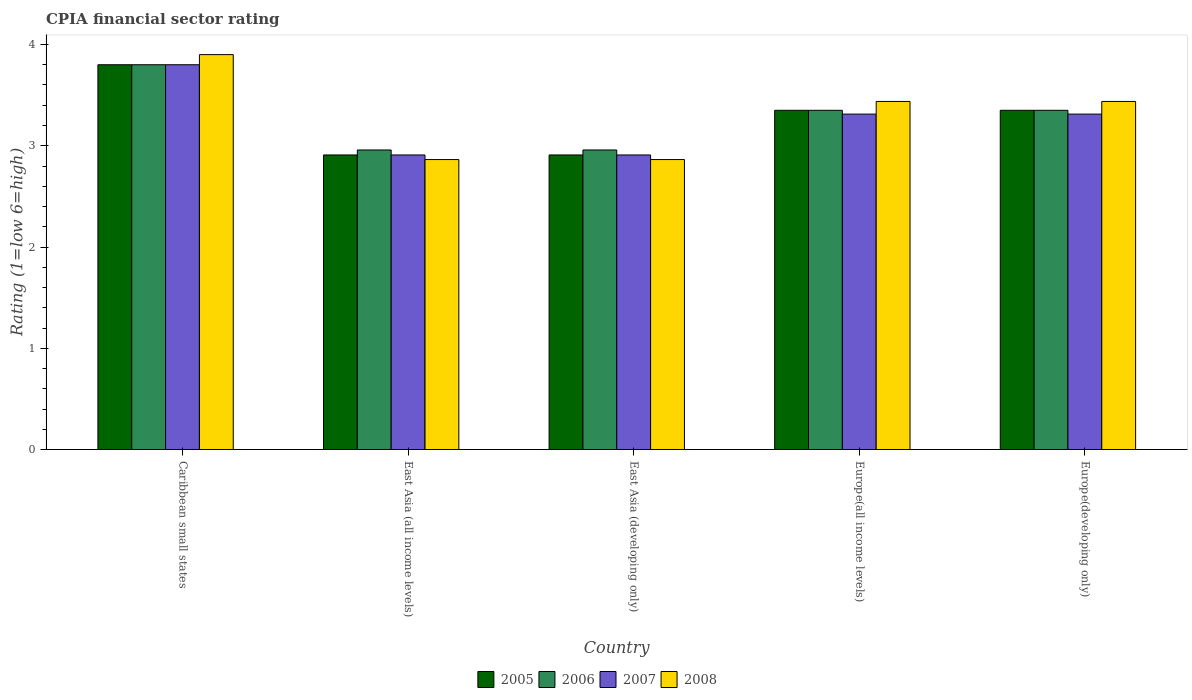How many different coloured bars are there?
Your answer should be very brief. 4. How many groups of bars are there?
Your answer should be very brief. 5. Are the number of bars per tick equal to the number of legend labels?
Offer a terse response. Yes. Are the number of bars on each tick of the X-axis equal?
Your answer should be compact. Yes. How many bars are there on the 1st tick from the right?
Offer a terse response. 4. What is the label of the 1st group of bars from the left?
Provide a succinct answer. Caribbean small states. In how many cases, is the number of bars for a given country not equal to the number of legend labels?
Make the answer very short. 0. What is the CPIA rating in 2005 in Europe(developing only)?
Offer a very short reply. 3.35. Across all countries, what is the minimum CPIA rating in 2005?
Offer a terse response. 2.91. In which country was the CPIA rating in 2005 maximum?
Provide a short and direct response. Caribbean small states. In which country was the CPIA rating in 2006 minimum?
Your answer should be compact. East Asia (all income levels). What is the total CPIA rating in 2006 in the graph?
Provide a succinct answer. 16.42. What is the difference between the CPIA rating in 2008 in Caribbean small states and that in East Asia (all income levels)?
Offer a very short reply. 1.04. What is the difference between the CPIA rating in 2006 in Europe(all income levels) and the CPIA rating in 2008 in East Asia (developing only)?
Keep it short and to the point. 0.49. What is the average CPIA rating in 2007 per country?
Your answer should be compact. 3.25. What is the difference between the CPIA rating of/in 2005 and CPIA rating of/in 2008 in East Asia (all income levels)?
Provide a succinct answer. 0.05. What is the ratio of the CPIA rating in 2007 in East Asia (developing only) to that in Europe(developing only)?
Offer a terse response. 0.88. What is the difference between the highest and the second highest CPIA rating in 2008?
Your response must be concise. -0.46. What is the difference between the highest and the lowest CPIA rating in 2008?
Ensure brevity in your answer.  1.04. Is the sum of the CPIA rating in 2007 in Caribbean small states and East Asia (developing only) greater than the maximum CPIA rating in 2005 across all countries?
Your answer should be very brief. Yes. What does the 2nd bar from the left in East Asia (developing only) represents?
Your response must be concise. 2006. What does the 2nd bar from the right in Caribbean small states represents?
Keep it short and to the point. 2007. Is it the case that in every country, the sum of the CPIA rating in 2007 and CPIA rating in 2008 is greater than the CPIA rating in 2005?
Offer a very short reply. Yes. How many bars are there?
Make the answer very short. 20. How many legend labels are there?
Your answer should be very brief. 4. What is the title of the graph?
Your response must be concise. CPIA financial sector rating. Does "2014" appear as one of the legend labels in the graph?
Give a very brief answer. No. What is the Rating (1=low 6=high) in 2008 in Caribbean small states?
Your response must be concise. 3.9. What is the Rating (1=low 6=high) in 2005 in East Asia (all income levels)?
Keep it short and to the point. 2.91. What is the Rating (1=low 6=high) in 2006 in East Asia (all income levels)?
Your response must be concise. 2.96. What is the Rating (1=low 6=high) in 2007 in East Asia (all income levels)?
Your answer should be very brief. 2.91. What is the Rating (1=low 6=high) of 2008 in East Asia (all income levels)?
Your answer should be very brief. 2.86. What is the Rating (1=low 6=high) of 2005 in East Asia (developing only)?
Provide a succinct answer. 2.91. What is the Rating (1=low 6=high) in 2006 in East Asia (developing only)?
Your answer should be compact. 2.96. What is the Rating (1=low 6=high) of 2007 in East Asia (developing only)?
Offer a terse response. 2.91. What is the Rating (1=low 6=high) in 2008 in East Asia (developing only)?
Provide a succinct answer. 2.86. What is the Rating (1=low 6=high) in 2005 in Europe(all income levels)?
Your response must be concise. 3.35. What is the Rating (1=low 6=high) in 2006 in Europe(all income levels)?
Give a very brief answer. 3.35. What is the Rating (1=low 6=high) of 2007 in Europe(all income levels)?
Keep it short and to the point. 3.31. What is the Rating (1=low 6=high) of 2008 in Europe(all income levels)?
Provide a short and direct response. 3.44. What is the Rating (1=low 6=high) of 2005 in Europe(developing only)?
Your answer should be very brief. 3.35. What is the Rating (1=low 6=high) in 2006 in Europe(developing only)?
Provide a succinct answer. 3.35. What is the Rating (1=low 6=high) of 2007 in Europe(developing only)?
Make the answer very short. 3.31. What is the Rating (1=low 6=high) in 2008 in Europe(developing only)?
Provide a short and direct response. 3.44. Across all countries, what is the maximum Rating (1=low 6=high) in 2005?
Your response must be concise. 3.8. Across all countries, what is the maximum Rating (1=low 6=high) in 2008?
Provide a short and direct response. 3.9. Across all countries, what is the minimum Rating (1=low 6=high) of 2005?
Your answer should be very brief. 2.91. Across all countries, what is the minimum Rating (1=low 6=high) of 2006?
Give a very brief answer. 2.96. Across all countries, what is the minimum Rating (1=low 6=high) of 2007?
Offer a very short reply. 2.91. Across all countries, what is the minimum Rating (1=low 6=high) in 2008?
Ensure brevity in your answer.  2.86. What is the total Rating (1=low 6=high) of 2005 in the graph?
Your answer should be very brief. 16.32. What is the total Rating (1=low 6=high) of 2006 in the graph?
Keep it short and to the point. 16.42. What is the total Rating (1=low 6=high) of 2007 in the graph?
Provide a succinct answer. 16.24. What is the total Rating (1=low 6=high) in 2008 in the graph?
Your response must be concise. 16.5. What is the difference between the Rating (1=low 6=high) of 2005 in Caribbean small states and that in East Asia (all income levels)?
Make the answer very short. 0.89. What is the difference between the Rating (1=low 6=high) in 2006 in Caribbean small states and that in East Asia (all income levels)?
Give a very brief answer. 0.84. What is the difference between the Rating (1=low 6=high) of 2007 in Caribbean small states and that in East Asia (all income levels)?
Your response must be concise. 0.89. What is the difference between the Rating (1=low 6=high) of 2008 in Caribbean small states and that in East Asia (all income levels)?
Give a very brief answer. 1.04. What is the difference between the Rating (1=low 6=high) of 2005 in Caribbean small states and that in East Asia (developing only)?
Ensure brevity in your answer.  0.89. What is the difference between the Rating (1=low 6=high) in 2006 in Caribbean small states and that in East Asia (developing only)?
Make the answer very short. 0.84. What is the difference between the Rating (1=low 6=high) in 2007 in Caribbean small states and that in East Asia (developing only)?
Keep it short and to the point. 0.89. What is the difference between the Rating (1=low 6=high) of 2008 in Caribbean small states and that in East Asia (developing only)?
Make the answer very short. 1.04. What is the difference between the Rating (1=low 6=high) in 2005 in Caribbean small states and that in Europe(all income levels)?
Your answer should be very brief. 0.45. What is the difference between the Rating (1=low 6=high) in 2006 in Caribbean small states and that in Europe(all income levels)?
Your answer should be very brief. 0.45. What is the difference between the Rating (1=low 6=high) in 2007 in Caribbean small states and that in Europe(all income levels)?
Your answer should be compact. 0.49. What is the difference between the Rating (1=low 6=high) of 2008 in Caribbean small states and that in Europe(all income levels)?
Offer a terse response. 0.46. What is the difference between the Rating (1=low 6=high) of 2005 in Caribbean small states and that in Europe(developing only)?
Make the answer very short. 0.45. What is the difference between the Rating (1=low 6=high) of 2006 in Caribbean small states and that in Europe(developing only)?
Offer a very short reply. 0.45. What is the difference between the Rating (1=low 6=high) in 2007 in Caribbean small states and that in Europe(developing only)?
Offer a very short reply. 0.49. What is the difference between the Rating (1=low 6=high) in 2008 in Caribbean small states and that in Europe(developing only)?
Offer a terse response. 0.46. What is the difference between the Rating (1=low 6=high) in 2005 in East Asia (all income levels) and that in East Asia (developing only)?
Keep it short and to the point. 0. What is the difference between the Rating (1=low 6=high) of 2008 in East Asia (all income levels) and that in East Asia (developing only)?
Provide a succinct answer. 0. What is the difference between the Rating (1=low 6=high) in 2005 in East Asia (all income levels) and that in Europe(all income levels)?
Provide a short and direct response. -0.44. What is the difference between the Rating (1=low 6=high) of 2006 in East Asia (all income levels) and that in Europe(all income levels)?
Keep it short and to the point. -0.39. What is the difference between the Rating (1=low 6=high) in 2007 in East Asia (all income levels) and that in Europe(all income levels)?
Your answer should be very brief. -0.4. What is the difference between the Rating (1=low 6=high) in 2008 in East Asia (all income levels) and that in Europe(all income levels)?
Offer a terse response. -0.57. What is the difference between the Rating (1=low 6=high) in 2005 in East Asia (all income levels) and that in Europe(developing only)?
Ensure brevity in your answer.  -0.44. What is the difference between the Rating (1=low 6=high) of 2006 in East Asia (all income levels) and that in Europe(developing only)?
Provide a short and direct response. -0.39. What is the difference between the Rating (1=low 6=high) of 2007 in East Asia (all income levels) and that in Europe(developing only)?
Offer a terse response. -0.4. What is the difference between the Rating (1=low 6=high) in 2008 in East Asia (all income levels) and that in Europe(developing only)?
Your answer should be compact. -0.57. What is the difference between the Rating (1=low 6=high) of 2005 in East Asia (developing only) and that in Europe(all income levels)?
Offer a very short reply. -0.44. What is the difference between the Rating (1=low 6=high) of 2006 in East Asia (developing only) and that in Europe(all income levels)?
Provide a short and direct response. -0.39. What is the difference between the Rating (1=low 6=high) of 2007 in East Asia (developing only) and that in Europe(all income levels)?
Give a very brief answer. -0.4. What is the difference between the Rating (1=low 6=high) in 2008 in East Asia (developing only) and that in Europe(all income levels)?
Offer a very short reply. -0.57. What is the difference between the Rating (1=low 6=high) in 2005 in East Asia (developing only) and that in Europe(developing only)?
Provide a succinct answer. -0.44. What is the difference between the Rating (1=low 6=high) of 2006 in East Asia (developing only) and that in Europe(developing only)?
Provide a short and direct response. -0.39. What is the difference between the Rating (1=low 6=high) in 2007 in East Asia (developing only) and that in Europe(developing only)?
Provide a short and direct response. -0.4. What is the difference between the Rating (1=low 6=high) of 2008 in East Asia (developing only) and that in Europe(developing only)?
Provide a succinct answer. -0.57. What is the difference between the Rating (1=low 6=high) in 2005 in Europe(all income levels) and that in Europe(developing only)?
Give a very brief answer. 0. What is the difference between the Rating (1=low 6=high) of 2006 in Europe(all income levels) and that in Europe(developing only)?
Provide a short and direct response. 0. What is the difference between the Rating (1=low 6=high) in 2007 in Europe(all income levels) and that in Europe(developing only)?
Offer a terse response. 0. What is the difference between the Rating (1=low 6=high) in 2005 in Caribbean small states and the Rating (1=low 6=high) in 2006 in East Asia (all income levels)?
Give a very brief answer. 0.84. What is the difference between the Rating (1=low 6=high) in 2005 in Caribbean small states and the Rating (1=low 6=high) in 2007 in East Asia (all income levels)?
Offer a very short reply. 0.89. What is the difference between the Rating (1=low 6=high) in 2005 in Caribbean small states and the Rating (1=low 6=high) in 2008 in East Asia (all income levels)?
Keep it short and to the point. 0.94. What is the difference between the Rating (1=low 6=high) of 2006 in Caribbean small states and the Rating (1=low 6=high) of 2007 in East Asia (all income levels)?
Your response must be concise. 0.89. What is the difference between the Rating (1=low 6=high) in 2006 in Caribbean small states and the Rating (1=low 6=high) in 2008 in East Asia (all income levels)?
Offer a very short reply. 0.94. What is the difference between the Rating (1=low 6=high) in 2007 in Caribbean small states and the Rating (1=low 6=high) in 2008 in East Asia (all income levels)?
Keep it short and to the point. 0.94. What is the difference between the Rating (1=low 6=high) in 2005 in Caribbean small states and the Rating (1=low 6=high) in 2006 in East Asia (developing only)?
Ensure brevity in your answer.  0.84. What is the difference between the Rating (1=low 6=high) in 2005 in Caribbean small states and the Rating (1=low 6=high) in 2007 in East Asia (developing only)?
Your response must be concise. 0.89. What is the difference between the Rating (1=low 6=high) in 2005 in Caribbean small states and the Rating (1=low 6=high) in 2008 in East Asia (developing only)?
Your answer should be very brief. 0.94. What is the difference between the Rating (1=low 6=high) in 2006 in Caribbean small states and the Rating (1=low 6=high) in 2007 in East Asia (developing only)?
Offer a terse response. 0.89. What is the difference between the Rating (1=low 6=high) in 2006 in Caribbean small states and the Rating (1=low 6=high) in 2008 in East Asia (developing only)?
Your answer should be very brief. 0.94. What is the difference between the Rating (1=low 6=high) of 2007 in Caribbean small states and the Rating (1=low 6=high) of 2008 in East Asia (developing only)?
Offer a terse response. 0.94. What is the difference between the Rating (1=low 6=high) of 2005 in Caribbean small states and the Rating (1=low 6=high) of 2006 in Europe(all income levels)?
Offer a very short reply. 0.45. What is the difference between the Rating (1=low 6=high) of 2005 in Caribbean small states and the Rating (1=low 6=high) of 2007 in Europe(all income levels)?
Make the answer very short. 0.49. What is the difference between the Rating (1=low 6=high) in 2005 in Caribbean small states and the Rating (1=low 6=high) in 2008 in Europe(all income levels)?
Your response must be concise. 0.36. What is the difference between the Rating (1=low 6=high) of 2006 in Caribbean small states and the Rating (1=low 6=high) of 2007 in Europe(all income levels)?
Keep it short and to the point. 0.49. What is the difference between the Rating (1=low 6=high) in 2006 in Caribbean small states and the Rating (1=low 6=high) in 2008 in Europe(all income levels)?
Provide a succinct answer. 0.36. What is the difference between the Rating (1=low 6=high) of 2007 in Caribbean small states and the Rating (1=low 6=high) of 2008 in Europe(all income levels)?
Offer a terse response. 0.36. What is the difference between the Rating (1=low 6=high) of 2005 in Caribbean small states and the Rating (1=low 6=high) of 2006 in Europe(developing only)?
Give a very brief answer. 0.45. What is the difference between the Rating (1=low 6=high) in 2005 in Caribbean small states and the Rating (1=low 6=high) in 2007 in Europe(developing only)?
Offer a terse response. 0.49. What is the difference between the Rating (1=low 6=high) of 2005 in Caribbean small states and the Rating (1=low 6=high) of 2008 in Europe(developing only)?
Your response must be concise. 0.36. What is the difference between the Rating (1=low 6=high) in 2006 in Caribbean small states and the Rating (1=low 6=high) in 2007 in Europe(developing only)?
Make the answer very short. 0.49. What is the difference between the Rating (1=low 6=high) in 2006 in Caribbean small states and the Rating (1=low 6=high) in 2008 in Europe(developing only)?
Keep it short and to the point. 0.36. What is the difference between the Rating (1=low 6=high) in 2007 in Caribbean small states and the Rating (1=low 6=high) in 2008 in Europe(developing only)?
Give a very brief answer. 0.36. What is the difference between the Rating (1=low 6=high) in 2005 in East Asia (all income levels) and the Rating (1=low 6=high) in 2006 in East Asia (developing only)?
Make the answer very short. -0.05. What is the difference between the Rating (1=low 6=high) in 2005 in East Asia (all income levels) and the Rating (1=low 6=high) in 2007 in East Asia (developing only)?
Offer a very short reply. 0. What is the difference between the Rating (1=low 6=high) of 2005 in East Asia (all income levels) and the Rating (1=low 6=high) of 2008 in East Asia (developing only)?
Provide a succinct answer. 0.05. What is the difference between the Rating (1=low 6=high) of 2006 in East Asia (all income levels) and the Rating (1=low 6=high) of 2007 in East Asia (developing only)?
Ensure brevity in your answer.  0.05. What is the difference between the Rating (1=low 6=high) of 2006 in East Asia (all income levels) and the Rating (1=low 6=high) of 2008 in East Asia (developing only)?
Your answer should be very brief. 0.09. What is the difference between the Rating (1=low 6=high) of 2007 in East Asia (all income levels) and the Rating (1=low 6=high) of 2008 in East Asia (developing only)?
Ensure brevity in your answer.  0.05. What is the difference between the Rating (1=low 6=high) of 2005 in East Asia (all income levels) and the Rating (1=low 6=high) of 2006 in Europe(all income levels)?
Your answer should be very brief. -0.44. What is the difference between the Rating (1=low 6=high) in 2005 in East Asia (all income levels) and the Rating (1=low 6=high) in 2007 in Europe(all income levels)?
Provide a succinct answer. -0.4. What is the difference between the Rating (1=low 6=high) of 2005 in East Asia (all income levels) and the Rating (1=low 6=high) of 2008 in Europe(all income levels)?
Provide a succinct answer. -0.53. What is the difference between the Rating (1=low 6=high) in 2006 in East Asia (all income levels) and the Rating (1=low 6=high) in 2007 in Europe(all income levels)?
Ensure brevity in your answer.  -0.35. What is the difference between the Rating (1=low 6=high) in 2006 in East Asia (all income levels) and the Rating (1=low 6=high) in 2008 in Europe(all income levels)?
Make the answer very short. -0.48. What is the difference between the Rating (1=low 6=high) of 2007 in East Asia (all income levels) and the Rating (1=low 6=high) of 2008 in Europe(all income levels)?
Make the answer very short. -0.53. What is the difference between the Rating (1=low 6=high) in 2005 in East Asia (all income levels) and the Rating (1=low 6=high) in 2006 in Europe(developing only)?
Provide a short and direct response. -0.44. What is the difference between the Rating (1=low 6=high) of 2005 in East Asia (all income levels) and the Rating (1=low 6=high) of 2007 in Europe(developing only)?
Provide a succinct answer. -0.4. What is the difference between the Rating (1=low 6=high) of 2005 in East Asia (all income levels) and the Rating (1=low 6=high) of 2008 in Europe(developing only)?
Provide a short and direct response. -0.53. What is the difference between the Rating (1=low 6=high) in 2006 in East Asia (all income levels) and the Rating (1=low 6=high) in 2007 in Europe(developing only)?
Make the answer very short. -0.35. What is the difference between the Rating (1=low 6=high) of 2006 in East Asia (all income levels) and the Rating (1=low 6=high) of 2008 in Europe(developing only)?
Offer a terse response. -0.48. What is the difference between the Rating (1=low 6=high) in 2007 in East Asia (all income levels) and the Rating (1=low 6=high) in 2008 in Europe(developing only)?
Give a very brief answer. -0.53. What is the difference between the Rating (1=low 6=high) in 2005 in East Asia (developing only) and the Rating (1=low 6=high) in 2006 in Europe(all income levels)?
Offer a terse response. -0.44. What is the difference between the Rating (1=low 6=high) of 2005 in East Asia (developing only) and the Rating (1=low 6=high) of 2007 in Europe(all income levels)?
Provide a succinct answer. -0.4. What is the difference between the Rating (1=low 6=high) in 2005 in East Asia (developing only) and the Rating (1=low 6=high) in 2008 in Europe(all income levels)?
Ensure brevity in your answer.  -0.53. What is the difference between the Rating (1=low 6=high) of 2006 in East Asia (developing only) and the Rating (1=low 6=high) of 2007 in Europe(all income levels)?
Your answer should be compact. -0.35. What is the difference between the Rating (1=low 6=high) of 2006 in East Asia (developing only) and the Rating (1=low 6=high) of 2008 in Europe(all income levels)?
Keep it short and to the point. -0.48. What is the difference between the Rating (1=low 6=high) of 2007 in East Asia (developing only) and the Rating (1=low 6=high) of 2008 in Europe(all income levels)?
Your answer should be very brief. -0.53. What is the difference between the Rating (1=low 6=high) of 2005 in East Asia (developing only) and the Rating (1=low 6=high) of 2006 in Europe(developing only)?
Your response must be concise. -0.44. What is the difference between the Rating (1=low 6=high) of 2005 in East Asia (developing only) and the Rating (1=low 6=high) of 2007 in Europe(developing only)?
Your answer should be compact. -0.4. What is the difference between the Rating (1=low 6=high) in 2005 in East Asia (developing only) and the Rating (1=low 6=high) in 2008 in Europe(developing only)?
Ensure brevity in your answer.  -0.53. What is the difference between the Rating (1=low 6=high) in 2006 in East Asia (developing only) and the Rating (1=low 6=high) in 2007 in Europe(developing only)?
Your answer should be compact. -0.35. What is the difference between the Rating (1=low 6=high) of 2006 in East Asia (developing only) and the Rating (1=low 6=high) of 2008 in Europe(developing only)?
Keep it short and to the point. -0.48. What is the difference between the Rating (1=low 6=high) of 2007 in East Asia (developing only) and the Rating (1=low 6=high) of 2008 in Europe(developing only)?
Give a very brief answer. -0.53. What is the difference between the Rating (1=low 6=high) in 2005 in Europe(all income levels) and the Rating (1=low 6=high) in 2006 in Europe(developing only)?
Your answer should be compact. 0. What is the difference between the Rating (1=low 6=high) in 2005 in Europe(all income levels) and the Rating (1=low 6=high) in 2007 in Europe(developing only)?
Provide a succinct answer. 0.04. What is the difference between the Rating (1=low 6=high) in 2005 in Europe(all income levels) and the Rating (1=low 6=high) in 2008 in Europe(developing only)?
Provide a succinct answer. -0.09. What is the difference between the Rating (1=low 6=high) of 2006 in Europe(all income levels) and the Rating (1=low 6=high) of 2007 in Europe(developing only)?
Offer a very short reply. 0.04. What is the difference between the Rating (1=low 6=high) in 2006 in Europe(all income levels) and the Rating (1=low 6=high) in 2008 in Europe(developing only)?
Your response must be concise. -0.09. What is the difference between the Rating (1=low 6=high) of 2007 in Europe(all income levels) and the Rating (1=low 6=high) of 2008 in Europe(developing only)?
Offer a terse response. -0.12. What is the average Rating (1=low 6=high) of 2005 per country?
Your answer should be compact. 3.26. What is the average Rating (1=low 6=high) in 2006 per country?
Offer a terse response. 3.28. What is the average Rating (1=low 6=high) of 2007 per country?
Keep it short and to the point. 3.25. What is the average Rating (1=low 6=high) of 2008 per country?
Your response must be concise. 3.3. What is the difference between the Rating (1=low 6=high) of 2005 and Rating (1=low 6=high) of 2006 in Caribbean small states?
Provide a succinct answer. 0. What is the difference between the Rating (1=low 6=high) in 2005 and Rating (1=low 6=high) in 2007 in Caribbean small states?
Ensure brevity in your answer.  0. What is the difference between the Rating (1=low 6=high) in 2007 and Rating (1=low 6=high) in 2008 in Caribbean small states?
Provide a short and direct response. -0.1. What is the difference between the Rating (1=low 6=high) in 2005 and Rating (1=low 6=high) in 2006 in East Asia (all income levels)?
Ensure brevity in your answer.  -0.05. What is the difference between the Rating (1=low 6=high) in 2005 and Rating (1=low 6=high) in 2008 in East Asia (all income levels)?
Your answer should be very brief. 0.05. What is the difference between the Rating (1=low 6=high) of 2006 and Rating (1=low 6=high) of 2007 in East Asia (all income levels)?
Your response must be concise. 0.05. What is the difference between the Rating (1=low 6=high) of 2006 and Rating (1=low 6=high) of 2008 in East Asia (all income levels)?
Provide a succinct answer. 0.09. What is the difference between the Rating (1=low 6=high) in 2007 and Rating (1=low 6=high) in 2008 in East Asia (all income levels)?
Give a very brief answer. 0.05. What is the difference between the Rating (1=low 6=high) in 2005 and Rating (1=low 6=high) in 2006 in East Asia (developing only)?
Provide a short and direct response. -0.05. What is the difference between the Rating (1=low 6=high) of 2005 and Rating (1=low 6=high) of 2008 in East Asia (developing only)?
Keep it short and to the point. 0.05. What is the difference between the Rating (1=low 6=high) of 2006 and Rating (1=low 6=high) of 2007 in East Asia (developing only)?
Keep it short and to the point. 0.05. What is the difference between the Rating (1=low 6=high) of 2006 and Rating (1=low 6=high) of 2008 in East Asia (developing only)?
Your response must be concise. 0.09. What is the difference between the Rating (1=low 6=high) of 2007 and Rating (1=low 6=high) of 2008 in East Asia (developing only)?
Provide a short and direct response. 0.05. What is the difference between the Rating (1=low 6=high) in 2005 and Rating (1=low 6=high) in 2006 in Europe(all income levels)?
Make the answer very short. 0. What is the difference between the Rating (1=low 6=high) of 2005 and Rating (1=low 6=high) of 2007 in Europe(all income levels)?
Your response must be concise. 0.04. What is the difference between the Rating (1=low 6=high) in 2005 and Rating (1=low 6=high) in 2008 in Europe(all income levels)?
Your response must be concise. -0.09. What is the difference between the Rating (1=low 6=high) of 2006 and Rating (1=low 6=high) of 2007 in Europe(all income levels)?
Give a very brief answer. 0.04. What is the difference between the Rating (1=low 6=high) in 2006 and Rating (1=low 6=high) in 2008 in Europe(all income levels)?
Provide a succinct answer. -0.09. What is the difference between the Rating (1=low 6=high) of 2007 and Rating (1=low 6=high) of 2008 in Europe(all income levels)?
Your answer should be very brief. -0.12. What is the difference between the Rating (1=low 6=high) in 2005 and Rating (1=low 6=high) in 2006 in Europe(developing only)?
Offer a very short reply. 0. What is the difference between the Rating (1=low 6=high) in 2005 and Rating (1=low 6=high) in 2007 in Europe(developing only)?
Provide a succinct answer. 0.04. What is the difference between the Rating (1=low 6=high) of 2005 and Rating (1=low 6=high) of 2008 in Europe(developing only)?
Give a very brief answer. -0.09. What is the difference between the Rating (1=low 6=high) of 2006 and Rating (1=low 6=high) of 2007 in Europe(developing only)?
Ensure brevity in your answer.  0.04. What is the difference between the Rating (1=low 6=high) of 2006 and Rating (1=low 6=high) of 2008 in Europe(developing only)?
Provide a short and direct response. -0.09. What is the difference between the Rating (1=low 6=high) of 2007 and Rating (1=low 6=high) of 2008 in Europe(developing only)?
Give a very brief answer. -0.12. What is the ratio of the Rating (1=low 6=high) of 2005 in Caribbean small states to that in East Asia (all income levels)?
Offer a terse response. 1.31. What is the ratio of the Rating (1=low 6=high) in 2006 in Caribbean small states to that in East Asia (all income levels)?
Keep it short and to the point. 1.28. What is the ratio of the Rating (1=low 6=high) of 2007 in Caribbean small states to that in East Asia (all income levels)?
Your answer should be compact. 1.31. What is the ratio of the Rating (1=low 6=high) of 2008 in Caribbean small states to that in East Asia (all income levels)?
Offer a very short reply. 1.36. What is the ratio of the Rating (1=low 6=high) in 2005 in Caribbean small states to that in East Asia (developing only)?
Offer a very short reply. 1.31. What is the ratio of the Rating (1=low 6=high) in 2006 in Caribbean small states to that in East Asia (developing only)?
Your answer should be compact. 1.28. What is the ratio of the Rating (1=low 6=high) in 2007 in Caribbean small states to that in East Asia (developing only)?
Provide a short and direct response. 1.31. What is the ratio of the Rating (1=low 6=high) of 2008 in Caribbean small states to that in East Asia (developing only)?
Make the answer very short. 1.36. What is the ratio of the Rating (1=low 6=high) of 2005 in Caribbean small states to that in Europe(all income levels)?
Make the answer very short. 1.13. What is the ratio of the Rating (1=low 6=high) in 2006 in Caribbean small states to that in Europe(all income levels)?
Offer a terse response. 1.13. What is the ratio of the Rating (1=low 6=high) in 2007 in Caribbean small states to that in Europe(all income levels)?
Offer a very short reply. 1.15. What is the ratio of the Rating (1=low 6=high) in 2008 in Caribbean small states to that in Europe(all income levels)?
Offer a very short reply. 1.13. What is the ratio of the Rating (1=low 6=high) in 2005 in Caribbean small states to that in Europe(developing only)?
Provide a succinct answer. 1.13. What is the ratio of the Rating (1=low 6=high) of 2006 in Caribbean small states to that in Europe(developing only)?
Your answer should be very brief. 1.13. What is the ratio of the Rating (1=low 6=high) of 2007 in Caribbean small states to that in Europe(developing only)?
Your response must be concise. 1.15. What is the ratio of the Rating (1=low 6=high) in 2008 in Caribbean small states to that in Europe(developing only)?
Your response must be concise. 1.13. What is the ratio of the Rating (1=low 6=high) in 2006 in East Asia (all income levels) to that in East Asia (developing only)?
Your answer should be compact. 1. What is the ratio of the Rating (1=low 6=high) in 2005 in East Asia (all income levels) to that in Europe(all income levels)?
Make the answer very short. 0.87. What is the ratio of the Rating (1=low 6=high) of 2006 in East Asia (all income levels) to that in Europe(all income levels)?
Ensure brevity in your answer.  0.88. What is the ratio of the Rating (1=low 6=high) in 2007 in East Asia (all income levels) to that in Europe(all income levels)?
Offer a very short reply. 0.88. What is the ratio of the Rating (1=low 6=high) of 2008 in East Asia (all income levels) to that in Europe(all income levels)?
Keep it short and to the point. 0.83. What is the ratio of the Rating (1=low 6=high) in 2005 in East Asia (all income levels) to that in Europe(developing only)?
Give a very brief answer. 0.87. What is the ratio of the Rating (1=low 6=high) in 2006 in East Asia (all income levels) to that in Europe(developing only)?
Provide a short and direct response. 0.88. What is the ratio of the Rating (1=low 6=high) of 2007 in East Asia (all income levels) to that in Europe(developing only)?
Your answer should be compact. 0.88. What is the ratio of the Rating (1=low 6=high) of 2008 in East Asia (all income levels) to that in Europe(developing only)?
Provide a succinct answer. 0.83. What is the ratio of the Rating (1=low 6=high) of 2005 in East Asia (developing only) to that in Europe(all income levels)?
Provide a succinct answer. 0.87. What is the ratio of the Rating (1=low 6=high) of 2006 in East Asia (developing only) to that in Europe(all income levels)?
Offer a very short reply. 0.88. What is the ratio of the Rating (1=low 6=high) in 2007 in East Asia (developing only) to that in Europe(all income levels)?
Provide a succinct answer. 0.88. What is the ratio of the Rating (1=low 6=high) of 2008 in East Asia (developing only) to that in Europe(all income levels)?
Your answer should be very brief. 0.83. What is the ratio of the Rating (1=low 6=high) in 2005 in East Asia (developing only) to that in Europe(developing only)?
Your response must be concise. 0.87. What is the ratio of the Rating (1=low 6=high) in 2006 in East Asia (developing only) to that in Europe(developing only)?
Give a very brief answer. 0.88. What is the ratio of the Rating (1=low 6=high) in 2007 in East Asia (developing only) to that in Europe(developing only)?
Offer a terse response. 0.88. What is the ratio of the Rating (1=low 6=high) of 2008 in East Asia (developing only) to that in Europe(developing only)?
Offer a very short reply. 0.83. What is the ratio of the Rating (1=low 6=high) in 2006 in Europe(all income levels) to that in Europe(developing only)?
Keep it short and to the point. 1. What is the ratio of the Rating (1=low 6=high) in 2007 in Europe(all income levels) to that in Europe(developing only)?
Provide a short and direct response. 1. What is the difference between the highest and the second highest Rating (1=low 6=high) of 2005?
Your response must be concise. 0.45. What is the difference between the highest and the second highest Rating (1=low 6=high) of 2006?
Your response must be concise. 0.45. What is the difference between the highest and the second highest Rating (1=low 6=high) in 2007?
Ensure brevity in your answer.  0.49. What is the difference between the highest and the second highest Rating (1=low 6=high) in 2008?
Give a very brief answer. 0.46. What is the difference between the highest and the lowest Rating (1=low 6=high) of 2005?
Offer a very short reply. 0.89. What is the difference between the highest and the lowest Rating (1=low 6=high) in 2006?
Keep it short and to the point. 0.84. What is the difference between the highest and the lowest Rating (1=low 6=high) of 2007?
Your answer should be compact. 0.89. What is the difference between the highest and the lowest Rating (1=low 6=high) in 2008?
Make the answer very short. 1.04. 